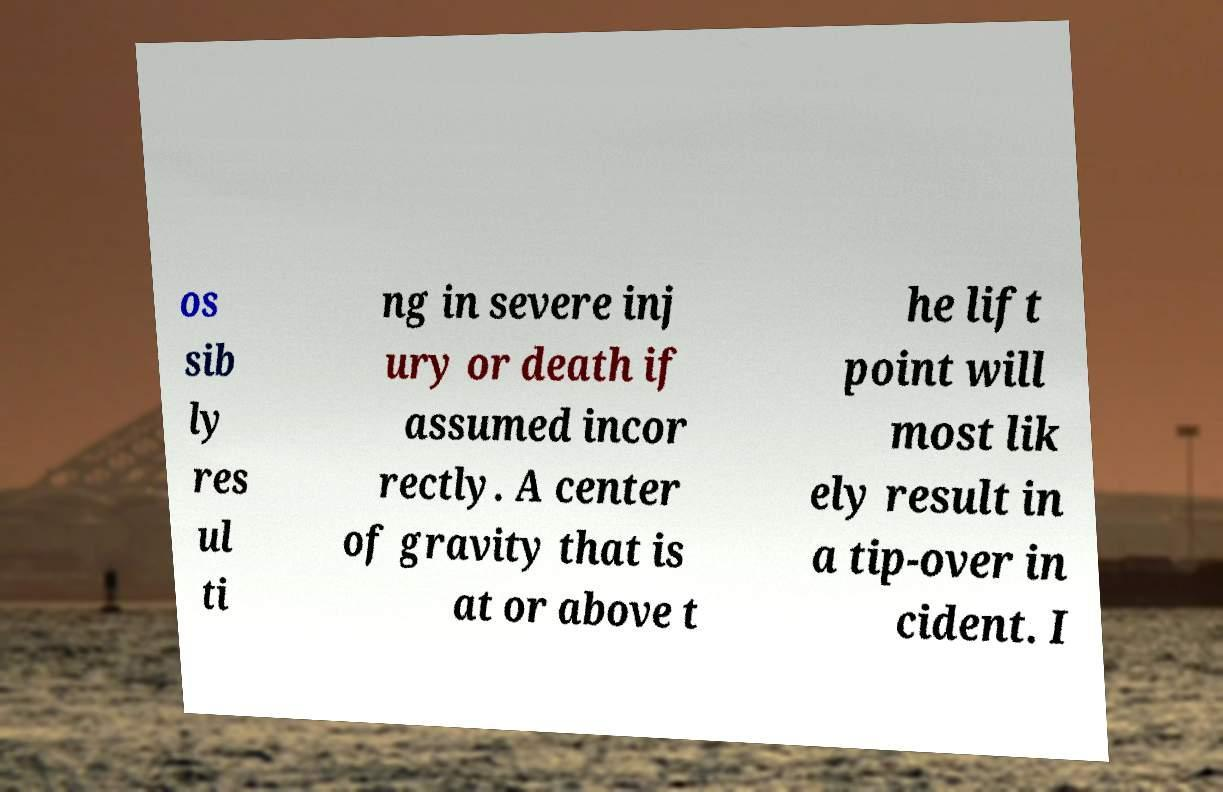Can you read and provide the text displayed in the image?This photo seems to have some interesting text. Can you extract and type it out for me? os sib ly res ul ti ng in severe inj ury or death if assumed incor rectly. A center of gravity that is at or above t he lift point will most lik ely result in a tip-over in cident. I 